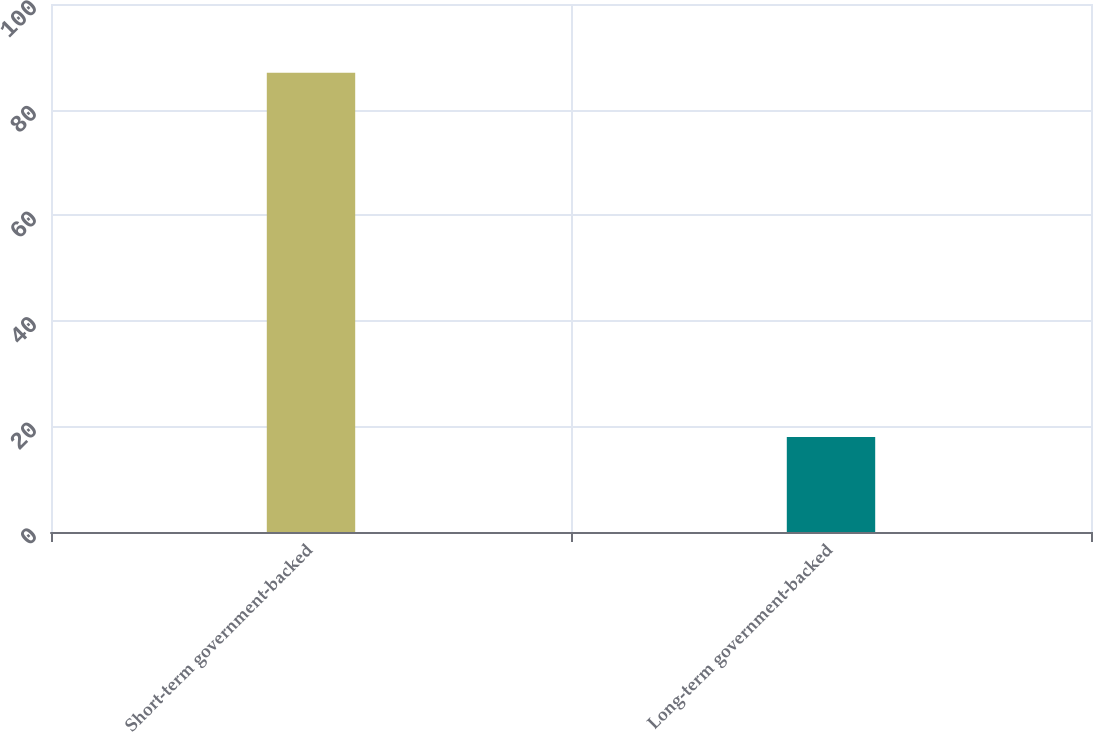<chart> <loc_0><loc_0><loc_500><loc_500><bar_chart><fcel>Short-term government-backed<fcel>Long-term government-backed<nl><fcel>87<fcel>18<nl></chart> 